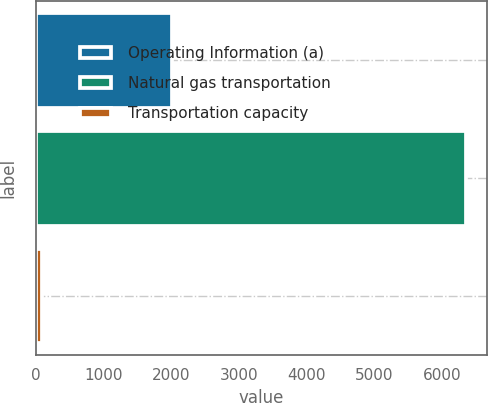<chart> <loc_0><loc_0><loc_500><loc_500><bar_chart><fcel>Operating Information (a)<fcel>Natural gas transportation<fcel>Transportation capacity<nl><fcel>2016<fcel>6345<fcel>92<nl></chart> 